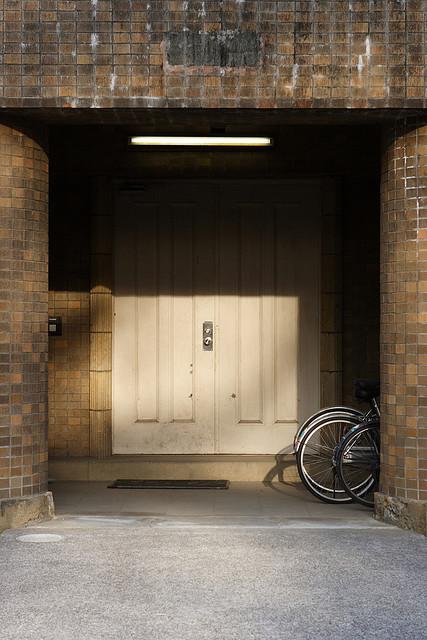What is parked near the columns?
Concise answer only. Bike. What is covering the upper half of the door?
Short answer required. Shadow. What color is the door?
Quick response, please. White. 